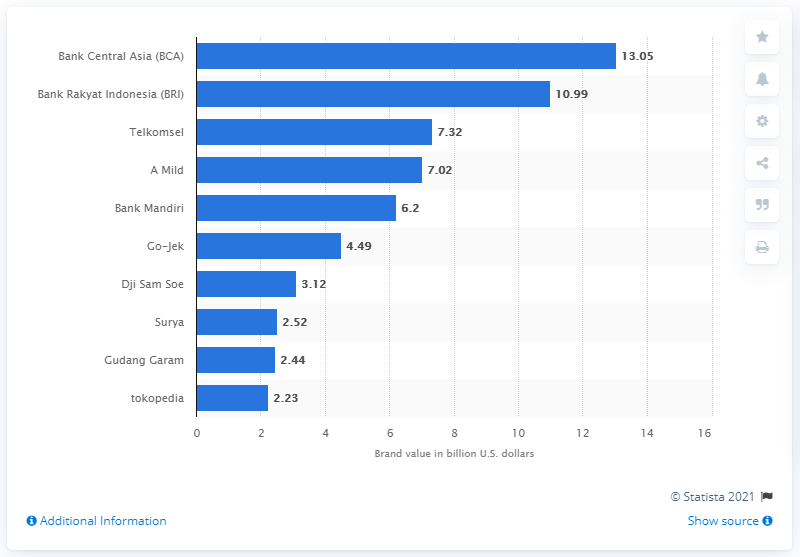What was Bank Central Asia's brand value in dollars in 2019?
 13.05 